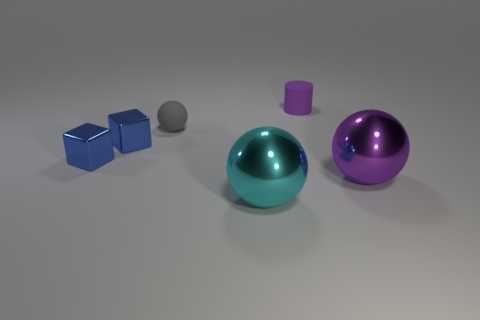Do the small thing on the right side of the cyan thing and the big purple metallic thing have the same shape?
Keep it short and to the point. No. Are there fewer cyan shiny objects that are behind the large cyan ball than purple things?
Your response must be concise. Yes. Is there a small metallic block that has the same color as the tiny matte cylinder?
Your answer should be compact. No. There is a purple matte object; does it have the same shape as the large thing on the left side of the big purple metallic thing?
Keep it short and to the point. No. Are there any purple spheres made of the same material as the purple cylinder?
Offer a terse response. No. Is there a purple object that is on the left side of the big ball to the left of the ball right of the tiny purple matte object?
Your response must be concise. No. How many other things are there of the same shape as the big cyan object?
Your response must be concise. 2. What color is the shiny sphere that is in front of the shiny sphere to the right of the large object that is in front of the purple sphere?
Make the answer very short. Cyan. What number of small cylinders are there?
Ensure brevity in your answer.  1. How many big things are either metal spheres or blocks?
Make the answer very short. 2. 